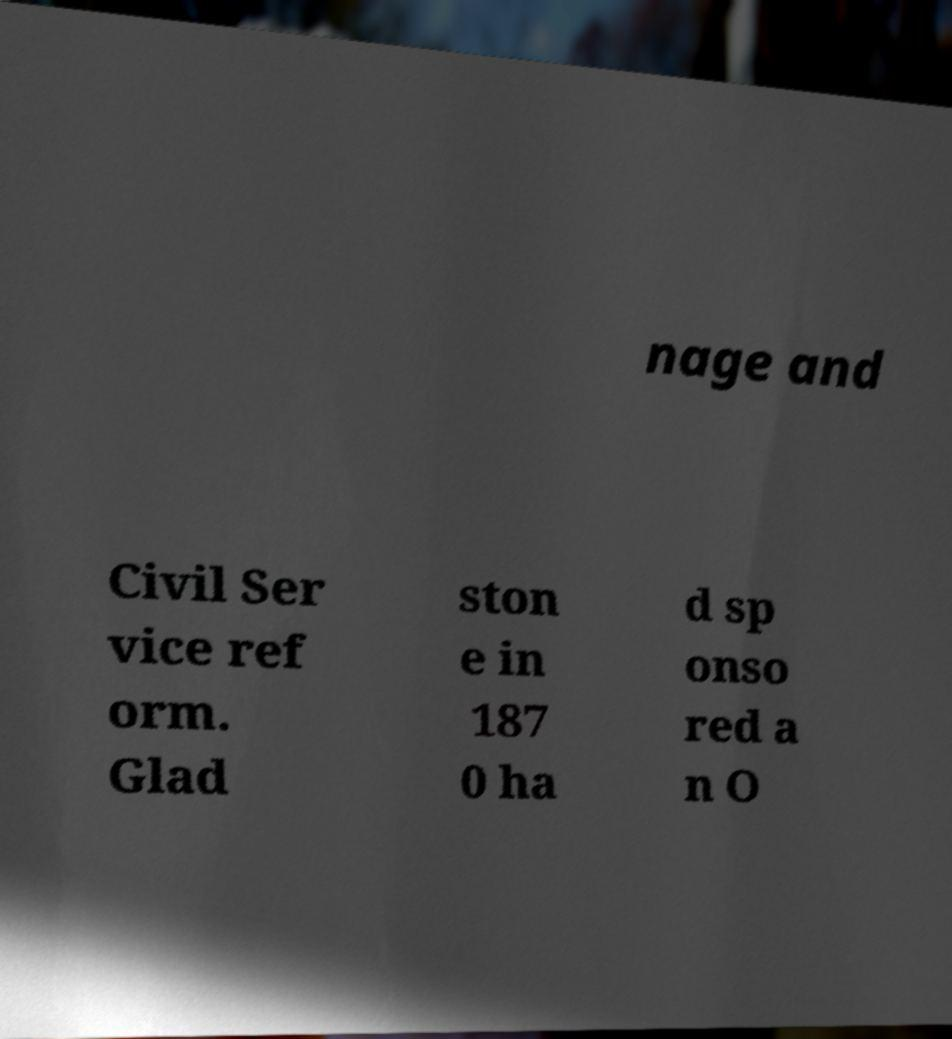For documentation purposes, I need the text within this image transcribed. Could you provide that? nage and Civil Ser vice ref orm. Glad ston e in 187 0 ha d sp onso red a n O 